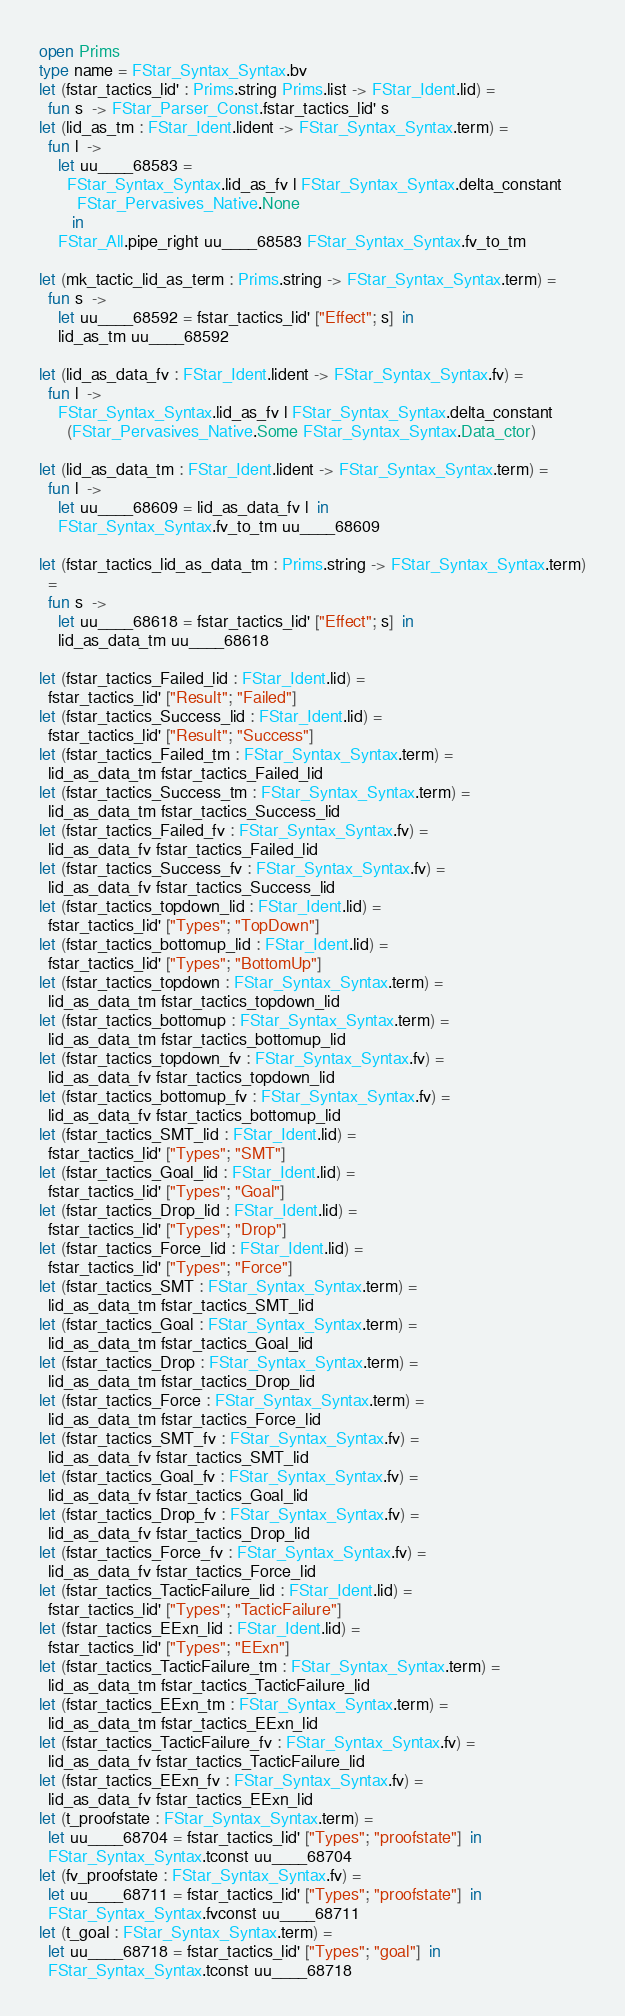Convert code to text. <code><loc_0><loc_0><loc_500><loc_500><_OCaml_>open Prims
type name = FStar_Syntax_Syntax.bv
let (fstar_tactics_lid' : Prims.string Prims.list -> FStar_Ident.lid) =
  fun s  -> FStar_Parser_Const.fstar_tactics_lid' s 
let (lid_as_tm : FStar_Ident.lident -> FStar_Syntax_Syntax.term) =
  fun l  ->
    let uu____68583 =
      FStar_Syntax_Syntax.lid_as_fv l FStar_Syntax_Syntax.delta_constant
        FStar_Pervasives_Native.None
       in
    FStar_All.pipe_right uu____68583 FStar_Syntax_Syntax.fv_to_tm
  
let (mk_tactic_lid_as_term : Prims.string -> FStar_Syntax_Syntax.term) =
  fun s  ->
    let uu____68592 = fstar_tactics_lid' ["Effect"; s]  in
    lid_as_tm uu____68592
  
let (lid_as_data_fv : FStar_Ident.lident -> FStar_Syntax_Syntax.fv) =
  fun l  ->
    FStar_Syntax_Syntax.lid_as_fv l FStar_Syntax_Syntax.delta_constant
      (FStar_Pervasives_Native.Some FStar_Syntax_Syntax.Data_ctor)
  
let (lid_as_data_tm : FStar_Ident.lident -> FStar_Syntax_Syntax.term) =
  fun l  ->
    let uu____68609 = lid_as_data_fv l  in
    FStar_Syntax_Syntax.fv_to_tm uu____68609
  
let (fstar_tactics_lid_as_data_tm : Prims.string -> FStar_Syntax_Syntax.term)
  =
  fun s  ->
    let uu____68618 = fstar_tactics_lid' ["Effect"; s]  in
    lid_as_data_tm uu____68618
  
let (fstar_tactics_Failed_lid : FStar_Ident.lid) =
  fstar_tactics_lid' ["Result"; "Failed"] 
let (fstar_tactics_Success_lid : FStar_Ident.lid) =
  fstar_tactics_lid' ["Result"; "Success"] 
let (fstar_tactics_Failed_tm : FStar_Syntax_Syntax.term) =
  lid_as_data_tm fstar_tactics_Failed_lid 
let (fstar_tactics_Success_tm : FStar_Syntax_Syntax.term) =
  lid_as_data_tm fstar_tactics_Success_lid 
let (fstar_tactics_Failed_fv : FStar_Syntax_Syntax.fv) =
  lid_as_data_fv fstar_tactics_Failed_lid 
let (fstar_tactics_Success_fv : FStar_Syntax_Syntax.fv) =
  lid_as_data_fv fstar_tactics_Success_lid 
let (fstar_tactics_topdown_lid : FStar_Ident.lid) =
  fstar_tactics_lid' ["Types"; "TopDown"] 
let (fstar_tactics_bottomup_lid : FStar_Ident.lid) =
  fstar_tactics_lid' ["Types"; "BottomUp"] 
let (fstar_tactics_topdown : FStar_Syntax_Syntax.term) =
  lid_as_data_tm fstar_tactics_topdown_lid 
let (fstar_tactics_bottomup : FStar_Syntax_Syntax.term) =
  lid_as_data_tm fstar_tactics_bottomup_lid 
let (fstar_tactics_topdown_fv : FStar_Syntax_Syntax.fv) =
  lid_as_data_fv fstar_tactics_topdown_lid 
let (fstar_tactics_bottomup_fv : FStar_Syntax_Syntax.fv) =
  lid_as_data_fv fstar_tactics_bottomup_lid 
let (fstar_tactics_SMT_lid : FStar_Ident.lid) =
  fstar_tactics_lid' ["Types"; "SMT"] 
let (fstar_tactics_Goal_lid : FStar_Ident.lid) =
  fstar_tactics_lid' ["Types"; "Goal"] 
let (fstar_tactics_Drop_lid : FStar_Ident.lid) =
  fstar_tactics_lid' ["Types"; "Drop"] 
let (fstar_tactics_Force_lid : FStar_Ident.lid) =
  fstar_tactics_lid' ["Types"; "Force"] 
let (fstar_tactics_SMT : FStar_Syntax_Syntax.term) =
  lid_as_data_tm fstar_tactics_SMT_lid 
let (fstar_tactics_Goal : FStar_Syntax_Syntax.term) =
  lid_as_data_tm fstar_tactics_Goal_lid 
let (fstar_tactics_Drop : FStar_Syntax_Syntax.term) =
  lid_as_data_tm fstar_tactics_Drop_lid 
let (fstar_tactics_Force : FStar_Syntax_Syntax.term) =
  lid_as_data_tm fstar_tactics_Force_lid 
let (fstar_tactics_SMT_fv : FStar_Syntax_Syntax.fv) =
  lid_as_data_fv fstar_tactics_SMT_lid 
let (fstar_tactics_Goal_fv : FStar_Syntax_Syntax.fv) =
  lid_as_data_fv fstar_tactics_Goal_lid 
let (fstar_tactics_Drop_fv : FStar_Syntax_Syntax.fv) =
  lid_as_data_fv fstar_tactics_Drop_lid 
let (fstar_tactics_Force_fv : FStar_Syntax_Syntax.fv) =
  lid_as_data_fv fstar_tactics_Force_lid 
let (fstar_tactics_TacticFailure_lid : FStar_Ident.lid) =
  fstar_tactics_lid' ["Types"; "TacticFailure"] 
let (fstar_tactics_EExn_lid : FStar_Ident.lid) =
  fstar_tactics_lid' ["Types"; "EExn"] 
let (fstar_tactics_TacticFailure_tm : FStar_Syntax_Syntax.term) =
  lid_as_data_tm fstar_tactics_TacticFailure_lid 
let (fstar_tactics_EExn_tm : FStar_Syntax_Syntax.term) =
  lid_as_data_tm fstar_tactics_EExn_lid 
let (fstar_tactics_TacticFailure_fv : FStar_Syntax_Syntax.fv) =
  lid_as_data_fv fstar_tactics_TacticFailure_lid 
let (fstar_tactics_EExn_fv : FStar_Syntax_Syntax.fv) =
  lid_as_data_fv fstar_tactics_EExn_lid 
let (t_proofstate : FStar_Syntax_Syntax.term) =
  let uu____68704 = fstar_tactics_lid' ["Types"; "proofstate"]  in
  FStar_Syntax_Syntax.tconst uu____68704 
let (fv_proofstate : FStar_Syntax_Syntax.fv) =
  let uu____68711 = fstar_tactics_lid' ["Types"; "proofstate"]  in
  FStar_Syntax_Syntax.fvconst uu____68711 
let (t_goal : FStar_Syntax_Syntax.term) =
  let uu____68718 = fstar_tactics_lid' ["Types"; "goal"]  in
  FStar_Syntax_Syntax.tconst uu____68718 </code> 